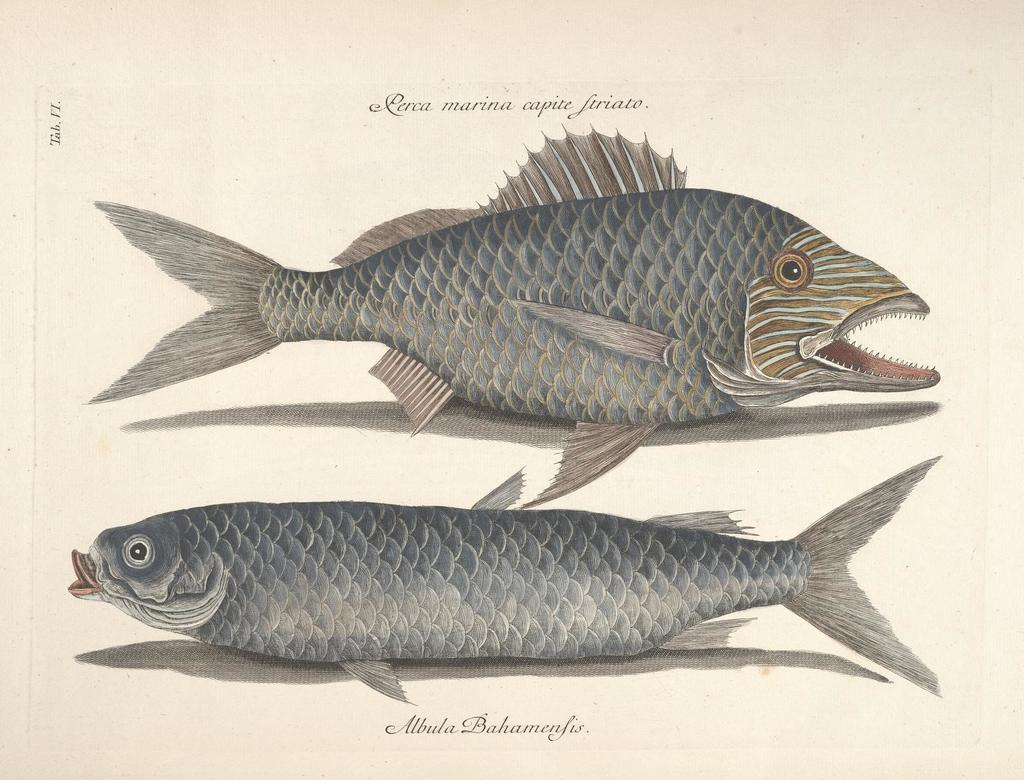What is the image printed on? The image is on a paper. How many types of fishes are depicted in the image? There are two different types of fishes depicted on the paper. Are there any other elements on the paper besides the fishes? Yes, there are letters on the paper. What type of alarm can be seen in the image? There is no alarm present in the image; it features two different types of fishes and letters on a paper. Can you tell me how many bombs are depicted in the image? There are no bombs depicted in the image; it features two different types of fishes and letters on a paper. 